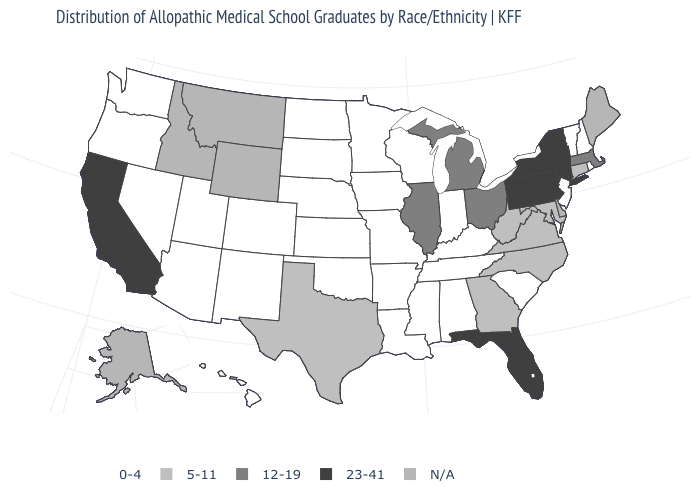Among the states that border South Dakota , which have the lowest value?
Quick response, please. Iowa, Minnesota, Nebraska, North Dakota. What is the lowest value in the USA?
Give a very brief answer. 0-4. What is the value of California?
Give a very brief answer. 23-41. What is the value of Montana?
Give a very brief answer. N/A. What is the highest value in the USA?
Keep it brief. 23-41. What is the lowest value in states that border Minnesota?
Quick response, please. 0-4. Does Florida have the lowest value in the South?
Concise answer only. No. Does Oregon have the highest value in the West?
Keep it brief. No. What is the value of Delaware?
Be succinct. N/A. Which states hav the highest value in the South?
Write a very short answer. Florida. What is the lowest value in states that border Minnesota?
Quick response, please. 0-4. What is the value of Idaho?
Quick response, please. N/A. Among the states that border Massachusetts , which have the lowest value?
Concise answer only. New Hampshire, Rhode Island, Vermont. Which states have the lowest value in the USA?
Short answer required. Alabama, Arizona, Arkansas, Colorado, Hawaii, Indiana, Iowa, Kansas, Kentucky, Louisiana, Minnesota, Mississippi, Missouri, Nebraska, Nevada, New Hampshire, New Jersey, New Mexico, North Dakota, Oklahoma, Oregon, Rhode Island, South Carolina, South Dakota, Tennessee, Utah, Vermont, Washington, Wisconsin. What is the highest value in the Northeast ?
Write a very short answer. 23-41. 